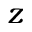Convert formula to latex. <formula><loc_0><loc_0><loc_500><loc_500>z</formula> 